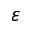Convert formula to latex. <formula><loc_0><loc_0><loc_500><loc_500>\varepsilon</formula> 